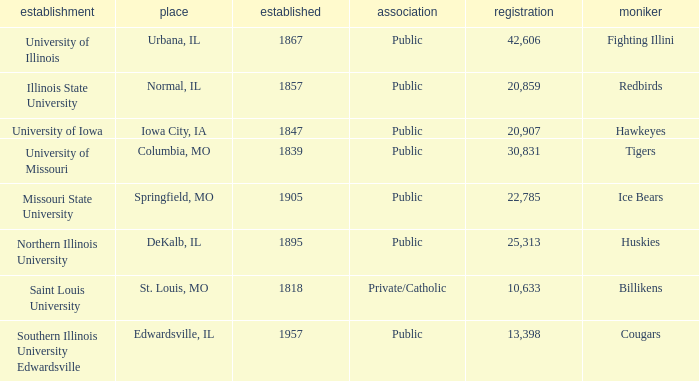What is the average enrollment of the Redbirds' school? 20859.0. 